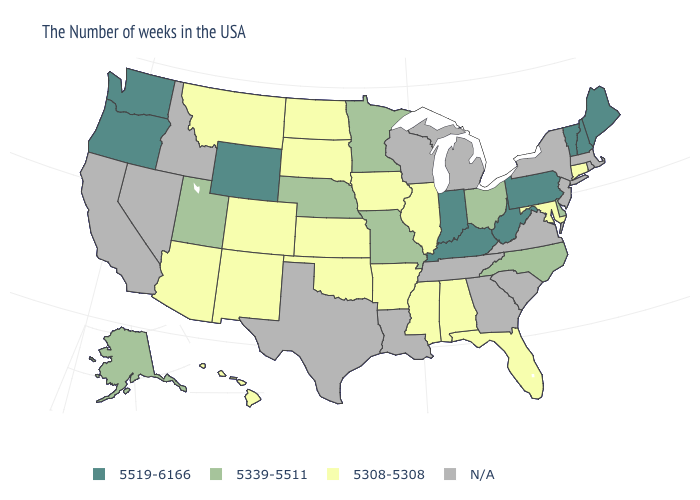How many symbols are there in the legend?
Quick response, please. 4. What is the lowest value in the USA?
Short answer required. 5308-5308. How many symbols are there in the legend?
Give a very brief answer. 4. Does Oklahoma have the lowest value in the USA?
Give a very brief answer. Yes. Name the states that have a value in the range 5519-6166?
Give a very brief answer. Maine, New Hampshire, Vermont, Pennsylvania, West Virginia, Kentucky, Indiana, Wyoming, Washington, Oregon. Name the states that have a value in the range 5308-5308?
Answer briefly. Connecticut, Maryland, Florida, Alabama, Illinois, Mississippi, Arkansas, Iowa, Kansas, Oklahoma, South Dakota, North Dakota, Colorado, New Mexico, Montana, Arizona, Hawaii. What is the value of Connecticut?
Write a very short answer. 5308-5308. Does New Hampshire have the lowest value in the USA?
Give a very brief answer. No. What is the value of Florida?
Quick response, please. 5308-5308. Does Oregon have the highest value in the USA?
Short answer required. Yes. Is the legend a continuous bar?
Keep it brief. No. What is the value of Mississippi?
Short answer required. 5308-5308. What is the highest value in the USA?
Answer briefly. 5519-6166. 